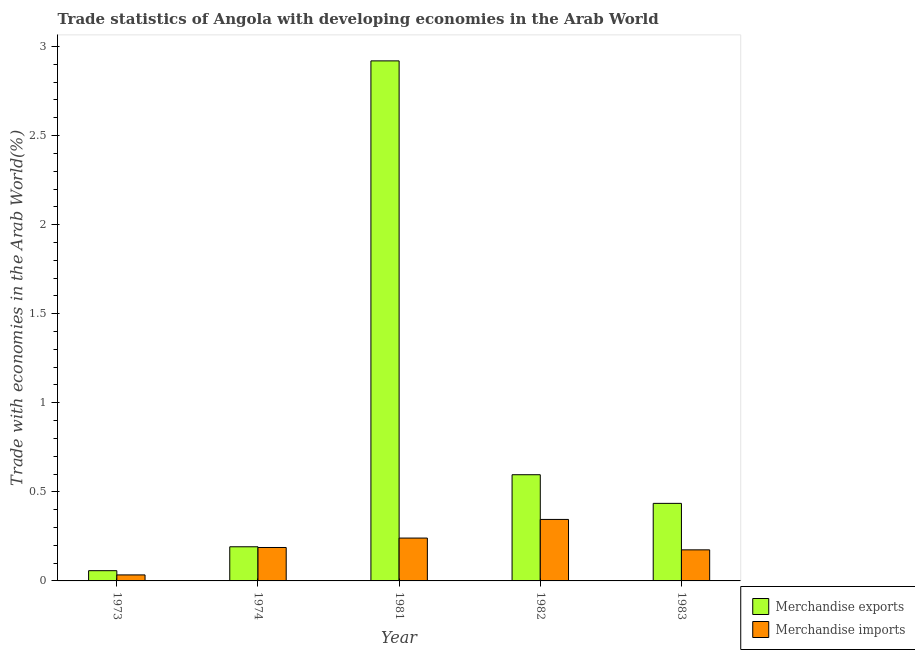How many different coloured bars are there?
Give a very brief answer. 2. How many bars are there on the 5th tick from the left?
Provide a short and direct response. 2. What is the label of the 3rd group of bars from the left?
Give a very brief answer. 1981. What is the merchandise exports in 1973?
Offer a very short reply. 0.06. Across all years, what is the maximum merchandise imports?
Provide a short and direct response. 0.35. Across all years, what is the minimum merchandise imports?
Your answer should be compact. 0.03. What is the total merchandise exports in the graph?
Provide a succinct answer. 4.2. What is the difference between the merchandise exports in 1973 and that in 1974?
Provide a short and direct response. -0.13. What is the difference between the merchandise exports in 1974 and the merchandise imports in 1981?
Keep it short and to the point. -2.73. What is the average merchandise exports per year?
Your answer should be compact. 0.84. In the year 1981, what is the difference between the merchandise imports and merchandise exports?
Your response must be concise. 0. In how many years, is the merchandise exports greater than 1.4 %?
Ensure brevity in your answer.  1. What is the ratio of the merchandise imports in 1982 to that in 1983?
Make the answer very short. 1.98. Is the merchandise imports in 1973 less than that in 1981?
Your answer should be compact. Yes. What is the difference between the highest and the second highest merchandise exports?
Your answer should be very brief. 2.32. What is the difference between the highest and the lowest merchandise exports?
Provide a succinct answer. 2.86. What does the 2nd bar from the left in 1982 represents?
Provide a short and direct response. Merchandise imports. What does the 2nd bar from the right in 1982 represents?
Give a very brief answer. Merchandise exports. Are the values on the major ticks of Y-axis written in scientific E-notation?
Give a very brief answer. No. What is the title of the graph?
Give a very brief answer. Trade statistics of Angola with developing economies in the Arab World. Does "Net savings(excluding particulate emission damage)" appear as one of the legend labels in the graph?
Keep it short and to the point. No. What is the label or title of the Y-axis?
Provide a short and direct response. Trade with economies in the Arab World(%). What is the Trade with economies in the Arab World(%) of Merchandise exports in 1973?
Your answer should be very brief. 0.06. What is the Trade with economies in the Arab World(%) in Merchandise imports in 1973?
Give a very brief answer. 0.03. What is the Trade with economies in the Arab World(%) in Merchandise exports in 1974?
Offer a very short reply. 0.19. What is the Trade with economies in the Arab World(%) of Merchandise imports in 1974?
Offer a terse response. 0.19. What is the Trade with economies in the Arab World(%) in Merchandise exports in 1981?
Your response must be concise. 2.92. What is the Trade with economies in the Arab World(%) in Merchandise imports in 1981?
Your answer should be very brief. 0.24. What is the Trade with economies in the Arab World(%) of Merchandise exports in 1982?
Make the answer very short. 0.6. What is the Trade with economies in the Arab World(%) of Merchandise imports in 1982?
Provide a succinct answer. 0.35. What is the Trade with economies in the Arab World(%) of Merchandise exports in 1983?
Give a very brief answer. 0.44. What is the Trade with economies in the Arab World(%) in Merchandise imports in 1983?
Make the answer very short. 0.17. Across all years, what is the maximum Trade with economies in the Arab World(%) in Merchandise exports?
Your answer should be compact. 2.92. Across all years, what is the maximum Trade with economies in the Arab World(%) in Merchandise imports?
Keep it short and to the point. 0.35. Across all years, what is the minimum Trade with economies in the Arab World(%) of Merchandise exports?
Ensure brevity in your answer.  0.06. Across all years, what is the minimum Trade with economies in the Arab World(%) of Merchandise imports?
Your answer should be very brief. 0.03. What is the total Trade with economies in the Arab World(%) in Merchandise exports in the graph?
Your answer should be very brief. 4.2. What is the total Trade with economies in the Arab World(%) of Merchandise imports in the graph?
Your answer should be very brief. 0.98. What is the difference between the Trade with economies in the Arab World(%) in Merchandise exports in 1973 and that in 1974?
Give a very brief answer. -0.13. What is the difference between the Trade with economies in the Arab World(%) of Merchandise imports in 1973 and that in 1974?
Make the answer very short. -0.15. What is the difference between the Trade with economies in the Arab World(%) of Merchandise exports in 1973 and that in 1981?
Ensure brevity in your answer.  -2.86. What is the difference between the Trade with economies in the Arab World(%) of Merchandise imports in 1973 and that in 1981?
Keep it short and to the point. -0.21. What is the difference between the Trade with economies in the Arab World(%) of Merchandise exports in 1973 and that in 1982?
Offer a very short reply. -0.54. What is the difference between the Trade with economies in the Arab World(%) in Merchandise imports in 1973 and that in 1982?
Make the answer very short. -0.31. What is the difference between the Trade with economies in the Arab World(%) in Merchandise exports in 1973 and that in 1983?
Make the answer very short. -0.38. What is the difference between the Trade with economies in the Arab World(%) of Merchandise imports in 1973 and that in 1983?
Ensure brevity in your answer.  -0.14. What is the difference between the Trade with economies in the Arab World(%) of Merchandise exports in 1974 and that in 1981?
Your response must be concise. -2.73. What is the difference between the Trade with economies in the Arab World(%) in Merchandise imports in 1974 and that in 1981?
Keep it short and to the point. -0.05. What is the difference between the Trade with economies in the Arab World(%) in Merchandise exports in 1974 and that in 1982?
Give a very brief answer. -0.4. What is the difference between the Trade with economies in the Arab World(%) in Merchandise imports in 1974 and that in 1982?
Keep it short and to the point. -0.16. What is the difference between the Trade with economies in the Arab World(%) of Merchandise exports in 1974 and that in 1983?
Keep it short and to the point. -0.24. What is the difference between the Trade with economies in the Arab World(%) in Merchandise imports in 1974 and that in 1983?
Your answer should be very brief. 0.01. What is the difference between the Trade with economies in the Arab World(%) in Merchandise exports in 1981 and that in 1982?
Give a very brief answer. 2.32. What is the difference between the Trade with economies in the Arab World(%) in Merchandise imports in 1981 and that in 1982?
Offer a very short reply. -0.1. What is the difference between the Trade with economies in the Arab World(%) in Merchandise exports in 1981 and that in 1983?
Your answer should be very brief. 2.48. What is the difference between the Trade with economies in the Arab World(%) of Merchandise imports in 1981 and that in 1983?
Give a very brief answer. 0.07. What is the difference between the Trade with economies in the Arab World(%) of Merchandise exports in 1982 and that in 1983?
Keep it short and to the point. 0.16. What is the difference between the Trade with economies in the Arab World(%) of Merchandise imports in 1982 and that in 1983?
Make the answer very short. 0.17. What is the difference between the Trade with economies in the Arab World(%) of Merchandise exports in 1973 and the Trade with economies in the Arab World(%) of Merchandise imports in 1974?
Your answer should be compact. -0.13. What is the difference between the Trade with economies in the Arab World(%) of Merchandise exports in 1973 and the Trade with economies in the Arab World(%) of Merchandise imports in 1981?
Make the answer very short. -0.18. What is the difference between the Trade with economies in the Arab World(%) of Merchandise exports in 1973 and the Trade with economies in the Arab World(%) of Merchandise imports in 1982?
Your answer should be very brief. -0.29. What is the difference between the Trade with economies in the Arab World(%) of Merchandise exports in 1973 and the Trade with economies in the Arab World(%) of Merchandise imports in 1983?
Offer a terse response. -0.12. What is the difference between the Trade with economies in the Arab World(%) in Merchandise exports in 1974 and the Trade with economies in the Arab World(%) in Merchandise imports in 1981?
Give a very brief answer. -0.05. What is the difference between the Trade with economies in the Arab World(%) of Merchandise exports in 1974 and the Trade with economies in the Arab World(%) of Merchandise imports in 1982?
Offer a terse response. -0.15. What is the difference between the Trade with economies in the Arab World(%) of Merchandise exports in 1974 and the Trade with economies in the Arab World(%) of Merchandise imports in 1983?
Give a very brief answer. 0.02. What is the difference between the Trade with economies in the Arab World(%) in Merchandise exports in 1981 and the Trade with economies in the Arab World(%) in Merchandise imports in 1982?
Give a very brief answer. 2.57. What is the difference between the Trade with economies in the Arab World(%) in Merchandise exports in 1981 and the Trade with economies in the Arab World(%) in Merchandise imports in 1983?
Offer a terse response. 2.75. What is the difference between the Trade with economies in the Arab World(%) of Merchandise exports in 1982 and the Trade with economies in the Arab World(%) of Merchandise imports in 1983?
Your answer should be compact. 0.42. What is the average Trade with economies in the Arab World(%) in Merchandise exports per year?
Your answer should be very brief. 0.84. What is the average Trade with economies in the Arab World(%) in Merchandise imports per year?
Your answer should be very brief. 0.2. In the year 1973, what is the difference between the Trade with economies in the Arab World(%) in Merchandise exports and Trade with economies in the Arab World(%) in Merchandise imports?
Offer a very short reply. 0.02. In the year 1974, what is the difference between the Trade with economies in the Arab World(%) of Merchandise exports and Trade with economies in the Arab World(%) of Merchandise imports?
Keep it short and to the point. 0. In the year 1981, what is the difference between the Trade with economies in the Arab World(%) of Merchandise exports and Trade with economies in the Arab World(%) of Merchandise imports?
Your answer should be compact. 2.68. In the year 1982, what is the difference between the Trade with economies in the Arab World(%) in Merchandise exports and Trade with economies in the Arab World(%) in Merchandise imports?
Give a very brief answer. 0.25. In the year 1983, what is the difference between the Trade with economies in the Arab World(%) in Merchandise exports and Trade with economies in the Arab World(%) in Merchandise imports?
Offer a very short reply. 0.26. What is the ratio of the Trade with economies in the Arab World(%) of Merchandise exports in 1973 to that in 1974?
Your response must be concise. 0.3. What is the ratio of the Trade with economies in the Arab World(%) in Merchandise imports in 1973 to that in 1974?
Offer a terse response. 0.18. What is the ratio of the Trade with economies in the Arab World(%) in Merchandise exports in 1973 to that in 1981?
Your response must be concise. 0.02. What is the ratio of the Trade with economies in the Arab World(%) in Merchandise imports in 1973 to that in 1981?
Your answer should be very brief. 0.14. What is the ratio of the Trade with economies in the Arab World(%) of Merchandise exports in 1973 to that in 1982?
Your answer should be very brief. 0.1. What is the ratio of the Trade with economies in the Arab World(%) in Merchandise imports in 1973 to that in 1982?
Give a very brief answer. 0.1. What is the ratio of the Trade with economies in the Arab World(%) of Merchandise exports in 1973 to that in 1983?
Offer a terse response. 0.13. What is the ratio of the Trade with economies in the Arab World(%) of Merchandise imports in 1973 to that in 1983?
Make the answer very short. 0.19. What is the ratio of the Trade with economies in the Arab World(%) in Merchandise exports in 1974 to that in 1981?
Ensure brevity in your answer.  0.07. What is the ratio of the Trade with economies in the Arab World(%) in Merchandise imports in 1974 to that in 1981?
Make the answer very short. 0.78. What is the ratio of the Trade with economies in the Arab World(%) in Merchandise exports in 1974 to that in 1982?
Ensure brevity in your answer.  0.32. What is the ratio of the Trade with economies in the Arab World(%) of Merchandise imports in 1974 to that in 1982?
Provide a succinct answer. 0.54. What is the ratio of the Trade with economies in the Arab World(%) in Merchandise exports in 1974 to that in 1983?
Ensure brevity in your answer.  0.44. What is the ratio of the Trade with economies in the Arab World(%) in Merchandise imports in 1974 to that in 1983?
Your response must be concise. 1.08. What is the ratio of the Trade with economies in the Arab World(%) in Merchandise exports in 1981 to that in 1982?
Your answer should be very brief. 4.9. What is the ratio of the Trade with economies in the Arab World(%) of Merchandise imports in 1981 to that in 1982?
Provide a succinct answer. 0.7. What is the ratio of the Trade with economies in the Arab World(%) in Merchandise exports in 1981 to that in 1983?
Offer a terse response. 6.71. What is the ratio of the Trade with economies in the Arab World(%) of Merchandise imports in 1981 to that in 1983?
Provide a short and direct response. 1.38. What is the ratio of the Trade with economies in the Arab World(%) of Merchandise exports in 1982 to that in 1983?
Ensure brevity in your answer.  1.37. What is the ratio of the Trade with economies in the Arab World(%) of Merchandise imports in 1982 to that in 1983?
Keep it short and to the point. 1.98. What is the difference between the highest and the second highest Trade with economies in the Arab World(%) in Merchandise exports?
Make the answer very short. 2.32. What is the difference between the highest and the second highest Trade with economies in the Arab World(%) in Merchandise imports?
Give a very brief answer. 0.1. What is the difference between the highest and the lowest Trade with economies in the Arab World(%) in Merchandise exports?
Your answer should be compact. 2.86. What is the difference between the highest and the lowest Trade with economies in the Arab World(%) in Merchandise imports?
Provide a succinct answer. 0.31. 